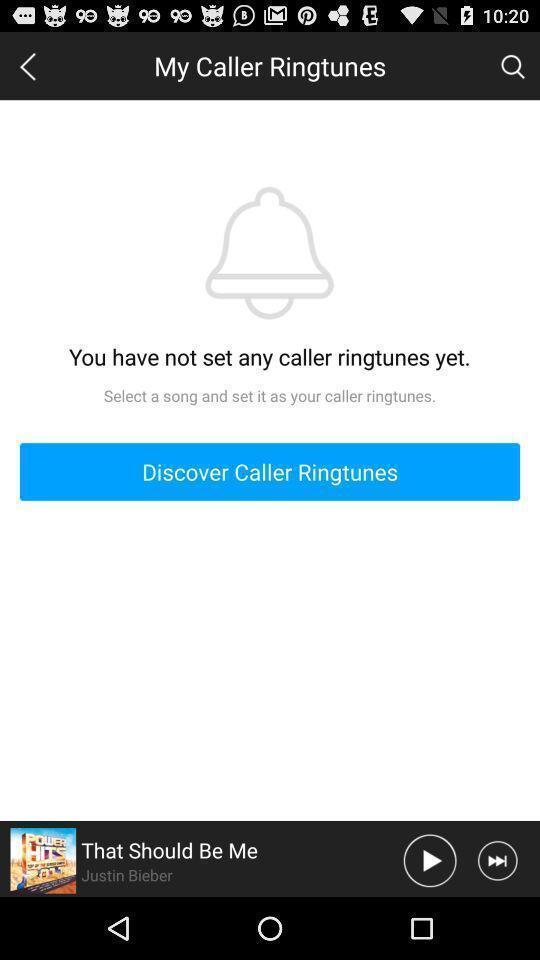Give me a narrative description of this picture. Page with an album paused and to set ringtones. 